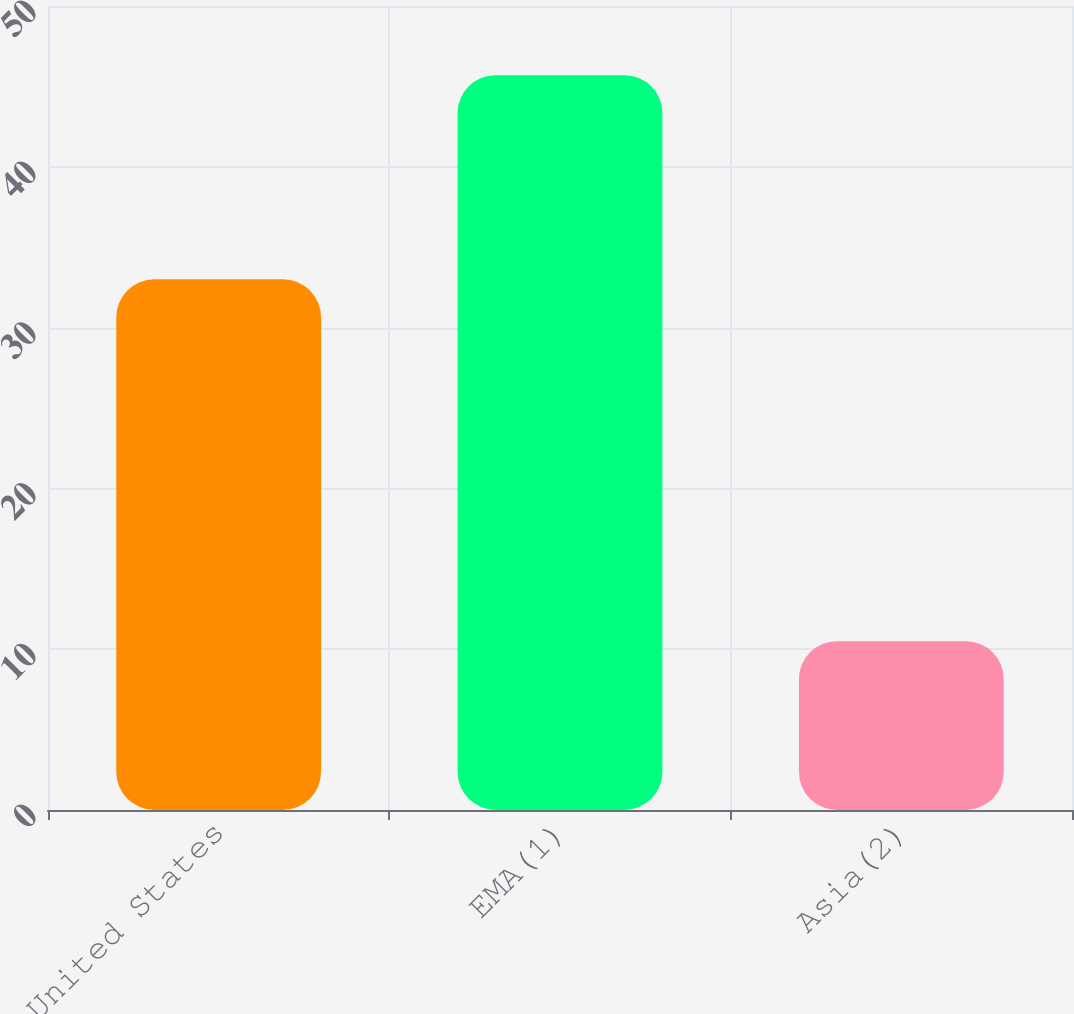Convert chart. <chart><loc_0><loc_0><loc_500><loc_500><bar_chart><fcel>United States<fcel>EMA(1)<fcel>Asia(2)<nl><fcel>33<fcel>45.7<fcel>10.5<nl></chart> 